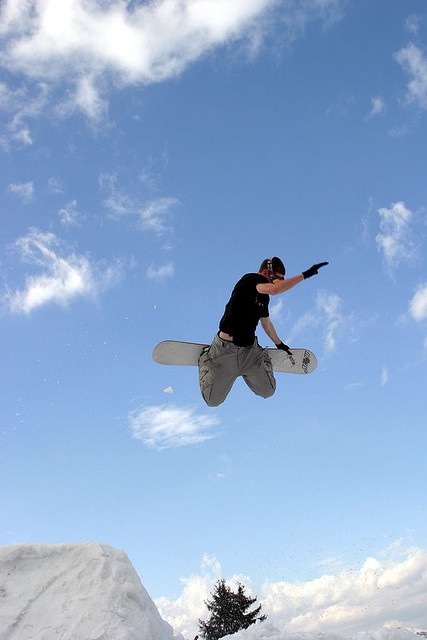Describe the objects in this image and their specific colors. I can see people in gray, black, brown, and lightblue tones and snowboard in gray and black tones in this image. 